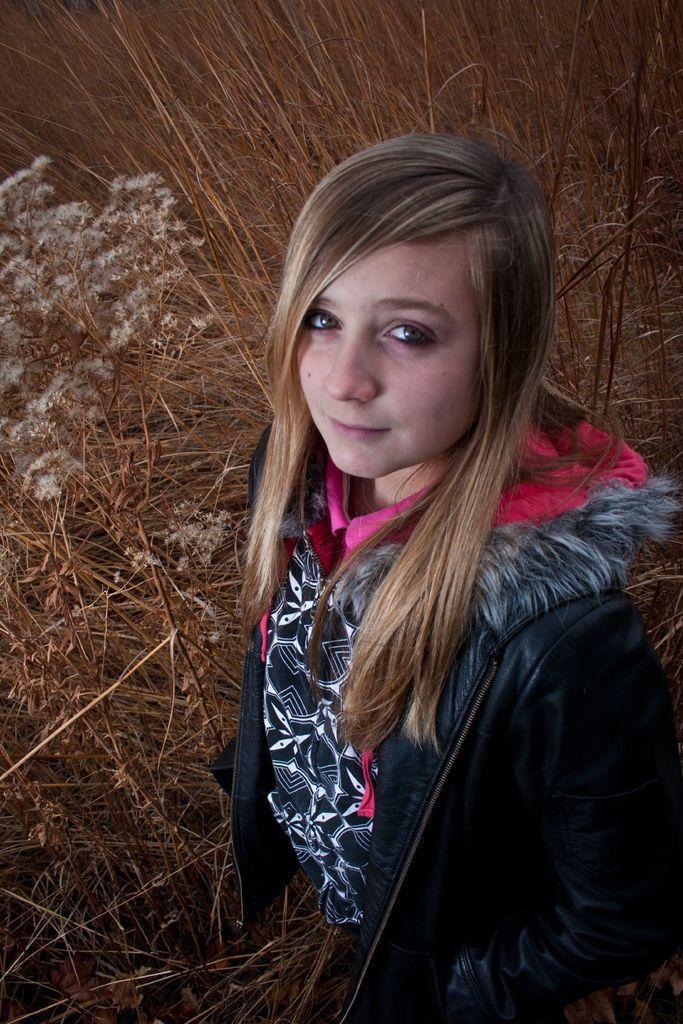Describe this image in one or two sentences. In the foreground of this picture, there is a girl in black jacket standing on the grass. In the background, we can see the grass. 